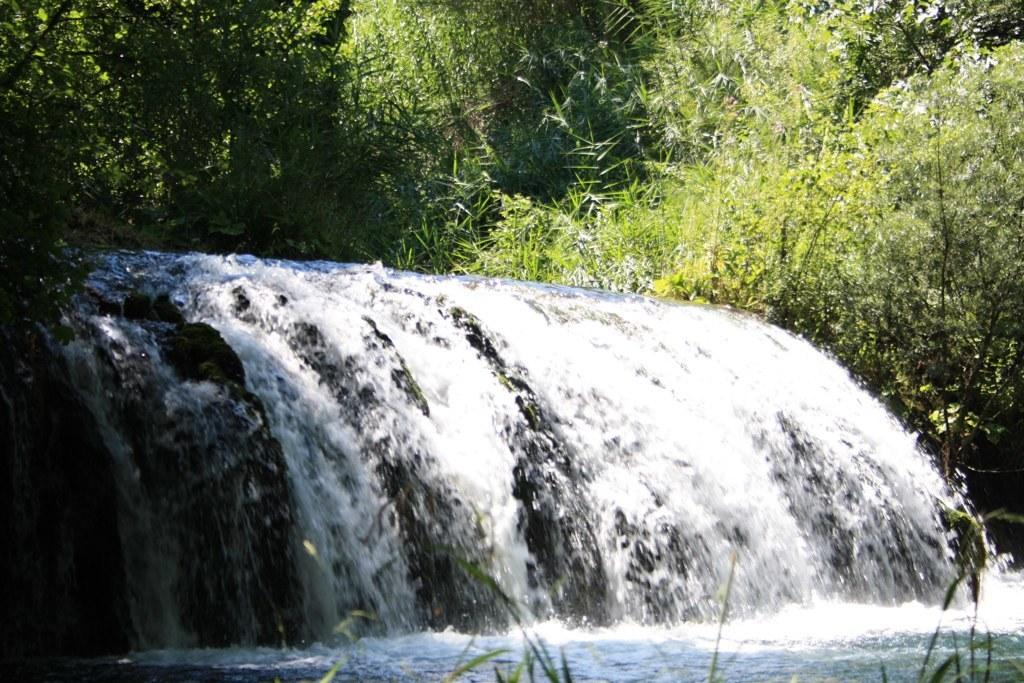What natural feature is the main subject of the image? There is a waterfall in the image. What type of vegetation can be seen in the image? There are trees in the image. What part of the trees can be seen in the image? There are leaves visible in the image. Who is the owner of the pet in the image? There is no pet present in the image. 